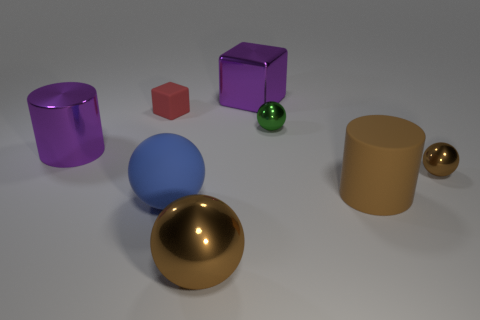How many spheres can you see, and what colors are they? There are four spheres in the image: one green, one tiny brownish or bronze sphere, one large blue sphere, and one gold or yellowish sphere. 